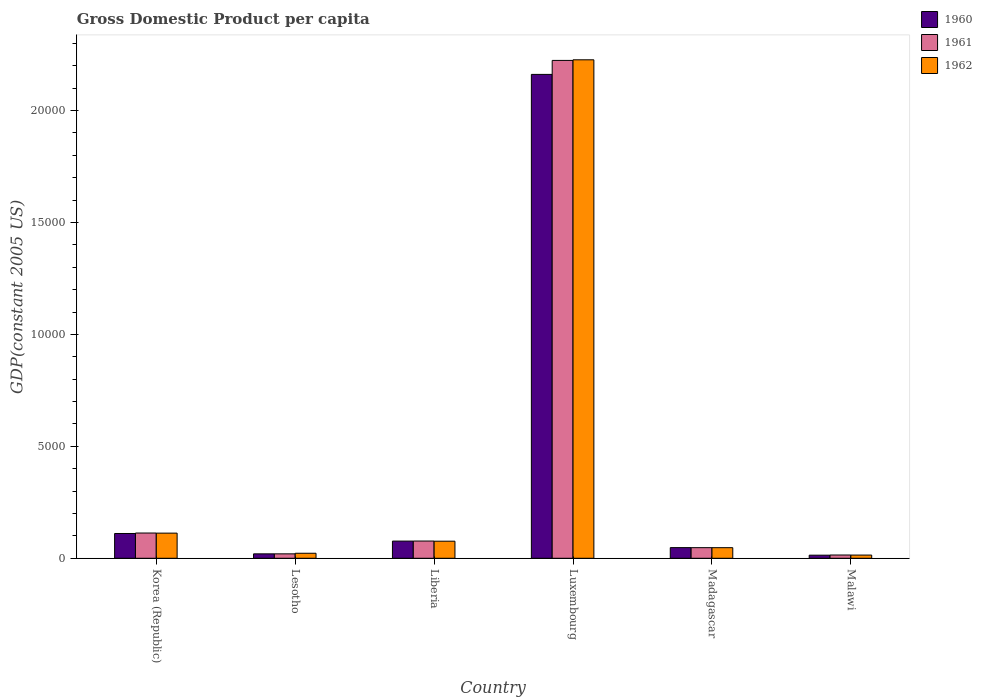How many different coloured bars are there?
Provide a short and direct response. 3. How many groups of bars are there?
Keep it short and to the point. 6. How many bars are there on the 2nd tick from the left?
Provide a succinct answer. 3. How many bars are there on the 3rd tick from the right?
Provide a short and direct response. 3. What is the label of the 1st group of bars from the left?
Your answer should be very brief. Korea (Republic). What is the GDP per capita in 1961 in Madagascar?
Keep it short and to the point. 473.7. Across all countries, what is the maximum GDP per capita in 1960?
Keep it short and to the point. 2.16e+04. Across all countries, what is the minimum GDP per capita in 1962?
Keep it short and to the point. 143.1. In which country was the GDP per capita in 1960 maximum?
Offer a very short reply. Luxembourg. In which country was the GDP per capita in 1962 minimum?
Your answer should be very brief. Malawi. What is the total GDP per capita in 1961 in the graph?
Give a very brief answer. 2.50e+04. What is the difference between the GDP per capita in 1960 in Liberia and that in Madagascar?
Ensure brevity in your answer.  292.1. What is the difference between the GDP per capita in 1961 in Madagascar and the GDP per capita in 1962 in Malawi?
Make the answer very short. 330.6. What is the average GDP per capita in 1960 per country?
Provide a succinct answer. 4049.82. What is the difference between the GDP per capita of/in 1962 and GDP per capita of/in 1961 in Lesotho?
Ensure brevity in your answer.  26.25. In how many countries, is the GDP per capita in 1962 greater than 1000 US$?
Ensure brevity in your answer.  2. What is the ratio of the GDP per capita in 1960 in Liberia to that in Luxembourg?
Your response must be concise. 0.04. What is the difference between the highest and the second highest GDP per capita in 1962?
Offer a very short reply. 2.11e+04. What is the difference between the highest and the lowest GDP per capita in 1962?
Your response must be concise. 2.21e+04. In how many countries, is the GDP per capita in 1960 greater than the average GDP per capita in 1960 taken over all countries?
Offer a terse response. 1. Is the sum of the GDP per capita in 1961 in Liberia and Madagascar greater than the maximum GDP per capita in 1962 across all countries?
Provide a succinct answer. No. What does the 1st bar from the left in Malawi represents?
Your response must be concise. 1960. How many bars are there?
Your answer should be very brief. 18. Are the values on the major ticks of Y-axis written in scientific E-notation?
Your answer should be compact. No. Where does the legend appear in the graph?
Offer a very short reply. Top right. How are the legend labels stacked?
Keep it short and to the point. Vertical. What is the title of the graph?
Offer a terse response. Gross Domestic Product per capita. What is the label or title of the Y-axis?
Keep it short and to the point. GDP(constant 2005 US). What is the GDP(constant 2005 US) of 1960 in Korea (Republic)?
Your answer should be very brief. 1106.76. What is the GDP(constant 2005 US) of 1961 in Korea (Republic)?
Provide a short and direct response. 1127.44. What is the GDP(constant 2005 US) in 1962 in Korea (Republic)?
Give a very brief answer. 1122.59. What is the GDP(constant 2005 US) in 1960 in Lesotho?
Keep it short and to the point. 197.38. What is the GDP(constant 2005 US) of 1961 in Lesotho?
Ensure brevity in your answer.  197.61. What is the GDP(constant 2005 US) in 1962 in Lesotho?
Offer a very short reply. 223.86. What is the GDP(constant 2005 US) in 1960 in Liberia?
Your answer should be very brief. 767.6. What is the GDP(constant 2005 US) of 1961 in Liberia?
Your answer should be very brief. 769.44. What is the GDP(constant 2005 US) of 1962 in Liberia?
Offer a very short reply. 762.88. What is the GDP(constant 2005 US) in 1960 in Luxembourg?
Provide a succinct answer. 2.16e+04. What is the GDP(constant 2005 US) of 1961 in Luxembourg?
Offer a terse response. 2.22e+04. What is the GDP(constant 2005 US) in 1962 in Luxembourg?
Offer a terse response. 2.23e+04. What is the GDP(constant 2005 US) in 1960 in Madagascar?
Provide a succinct answer. 475.5. What is the GDP(constant 2005 US) of 1961 in Madagascar?
Offer a very short reply. 473.7. What is the GDP(constant 2005 US) of 1962 in Madagascar?
Keep it short and to the point. 472.78. What is the GDP(constant 2005 US) of 1960 in Malawi?
Give a very brief answer. 138.11. What is the GDP(constant 2005 US) in 1961 in Malawi?
Give a very brief answer. 145.39. What is the GDP(constant 2005 US) of 1962 in Malawi?
Your response must be concise. 143.1. Across all countries, what is the maximum GDP(constant 2005 US) of 1960?
Provide a short and direct response. 2.16e+04. Across all countries, what is the maximum GDP(constant 2005 US) of 1961?
Your response must be concise. 2.22e+04. Across all countries, what is the maximum GDP(constant 2005 US) of 1962?
Your answer should be compact. 2.23e+04. Across all countries, what is the minimum GDP(constant 2005 US) in 1960?
Keep it short and to the point. 138.11. Across all countries, what is the minimum GDP(constant 2005 US) of 1961?
Make the answer very short. 145.39. Across all countries, what is the minimum GDP(constant 2005 US) in 1962?
Provide a short and direct response. 143.1. What is the total GDP(constant 2005 US) of 1960 in the graph?
Your answer should be very brief. 2.43e+04. What is the total GDP(constant 2005 US) in 1961 in the graph?
Offer a very short reply. 2.50e+04. What is the total GDP(constant 2005 US) of 1962 in the graph?
Your response must be concise. 2.50e+04. What is the difference between the GDP(constant 2005 US) of 1960 in Korea (Republic) and that in Lesotho?
Provide a short and direct response. 909.38. What is the difference between the GDP(constant 2005 US) of 1961 in Korea (Republic) and that in Lesotho?
Make the answer very short. 929.82. What is the difference between the GDP(constant 2005 US) in 1962 in Korea (Republic) and that in Lesotho?
Provide a succinct answer. 898.73. What is the difference between the GDP(constant 2005 US) in 1960 in Korea (Republic) and that in Liberia?
Make the answer very short. 339.16. What is the difference between the GDP(constant 2005 US) of 1961 in Korea (Republic) and that in Liberia?
Provide a short and direct response. 357.99. What is the difference between the GDP(constant 2005 US) of 1962 in Korea (Republic) and that in Liberia?
Provide a succinct answer. 359.71. What is the difference between the GDP(constant 2005 US) of 1960 in Korea (Republic) and that in Luxembourg?
Offer a very short reply. -2.05e+04. What is the difference between the GDP(constant 2005 US) of 1961 in Korea (Republic) and that in Luxembourg?
Provide a short and direct response. -2.11e+04. What is the difference between the GDP(constant 2005 US) of 1962 in Korea (Republic) and that in Luxembourg?
Make the answer very short. -2.11e+04. What is the difference between the GDP(constant 2005 US) in 1960 in Korea (Republic) and that in Madagascar?
Provide a succinct answer. 631.26. What is the difference between the GDP(constant 2005 US) in 1961 in Korea (Republic) and that in Madagascar?
Provide a succinct answer. 653.74. What is the difference between the GDP(constant 2005 US) of 1962 in Korea (Republic) and that in Madagascar?
Give a very brief answer. 649.82. What is the difference between the GDP(constant 2005 US) of 1960 in Korea (Republic) and that in Malawi?
Your answer should be compact. 968.65. What is the difference between the GDP(constant 2005 US) in 1961 in Korea (Republic) and that in Malawi?
Provide a short and direct response. 982.05. What is the difference between the GDP(constant 2005 US) in 1962 in Korea (Republic) and that in Malawi?
Give a very brief answer. 979.49. What is the difference between the GDP(constant 2005 US) in 1960 in Lesotho and that in Liberia?
Provide a short and direct response. -570.22. What is the difference between the GDP(constant 2005 US) of 1961 in Lesotho and that in Liberia?
Provide a short and direct response. -571.83. What is the difference between the GDP(constant 2005 US) of 1962 in Lesotho and that in Liberia?
Provide a succinct answer. -539.02. What is the difference between the GDP(constant 2005 US) of 1960 in Lesotho and that in Luxembourg?
Ensure brevity in your answer.  -2.14e+04. What is the difference between the GDP(constant 2005 US) in 1961 in Lesotho and that in Luxembourg?
Give a very brief answer. -2.20e+04. What is the difference between the GDP(constant 2005 US) in 1962 in Lesotho and that in Luxembourg?
Your response must be concise. -2.20e+04. What is the difference between the GDP(constant 2005 US) of 1960 in Lesotho and that in Madagascar?
Your answer should be very brief. -278.12. What is the difference between the GDP(constant 2005 US) in 1961 in Lesotho and that in Madagascar?
Give a very brief answer. -276.09. What is the difference between the GDP(constant 2005 US) of 1962 in Lesotho and that in Madagascar?
Your answer should be very brief. -248.91. What is the difference between the GDP(constant 2005 US) of 1960 in Lesotho and that in Malawi?
Keep it short and to the point. 59.27. What is the difference between the GDP(constant 2005 US) of 1961 in Lesotho and that in Malawi?
Keep it short and to the point. 52.22. What is the difference between the GDP(constant 2005 US) of 1962 in Lesotho and that in Malawi?
Provide a short and direct response. 80.77. What is the difference between the GDP(constant 2005 US) of 1960 in Liberia and that in Luxembourg?
Provide a succinct answer. -2.08e+04. What is the difference between the GDP(constant 2005 US) in 1961 in Liberia and that in Luxembourg?
Make the answer very short. -2.15e+04. What is the difference between the GDP(constant 2005 US) of 1962 in Liberia and that in Luxembourg?
Ensure brevity in your answer.  -2.15e+04. What is the difference between the GDP(constant 2005 US) in 1960 in Liberia and that in Madagascar?
Your answer should be very brief. 292.1. What is the difference between the GDP(constant 2005 US) of 1961 in Liberia and that in Madagascar?
Your response must be concise. 295.74. What is the difference between the GDP(constant 2005 US) of 1962 in Liberia and that in Madagascar?
Ensure brevity in your answer.  290.11. What is the difference between the GDP(constant 2005 US) of 1960 in Liberia and that in Malawi?
Your response must be concise. 629.48. What is the difference between the GDP(constant 2005 US) in 1961 in Liberia and that in Malawi?
Keep it short and to the point. 624.05. What is the difference between the GDP(constant 2005 US) of 1962 in Liberia and that in Malawi?
Give a very brief answer. 619.78. What is the difference between the GDP(constant 2005 US) of 1960 in Luxembourg and that in Madagascar?
Your answer should be very brief. 2.11e+04. What is the difference between the GDP(constant 2005 US) in 1961 in Luxembourg and that in Madagascar?
Ensure brevity in your answer.  2.18e+04. What is the difference between the GDP(constant 2005 US) in 1962 in Luxembourg and that in Madagascar?
Offer a very short reply. 2.18e+04. What is the difference between the GDP(constant 2005 US) of 1960 in Luxembourg and that in Malawi?
Provide a succinct answer. 2.15e+04. What is the difference between the GDP(constant 2005 US) in 1961 in Luxembourg and that in Malawi?
Your answer should be very brief. 2.21e+04. What is the difference between the GDP(constant 2005 US) in 1962 in Luxembourg and that in Malawi?
Give a very brief answer. 2.21e+04. What is the difference between the GDP(constant 2005 US) of 1960 in Madagascar and that in Malawi?
Give a very brief answer. 337.39. What is the difference between the GDP(constant 2005 US) of 1961 in Madagascar and that in Malawi?
Make the answer very short. 328.31. What is the difference between the GDP(constant 2005 US) of 1962 in Madagascar and that in Malawi?
Keep it short and to the point. 329.68. What is the difference between the GDP(constant 2005 US) of 1960 in Korea (Republic) and the GDP(constant 2005 US) of 1961 in Lesotho?
Provide a succinct answer. 909.15. What is the difference between the GDP(constant 2005 US) in 1960 in Korea (Republic) and the GDP(constant 2005 US) in 1962 in Lesotho?
Offer a terse response. 882.89. What is the difference between the GDP(constant 2005 US) in 1961 in Korea (Republic) and the GDP(constant 2005 US) in 1962 in Lesotho?
Your response must be concise. 903.57. What is the difference between the GDP(constant 2005 US) of 1960 in Korea (Republic) and the GDP(constant 2005 US) of 1961 in Liberia?
Keep it short and to the point. 337.32. What is the difference between the GDP(constant 2005 US) of 1960 in Korea (Republic) and the GDP(constant 2005 US) of 1962 in Liberia?
Provide a short and direct response. 343.88. What is the difference between the GDP(constant 2005 US) of 1961 in Korea (Republic) and the GDP(constant 2005 US) of 1962 in Liberia?
Offer a very short reply. 364.55. What is the difference between the GDP(constant 2005 US) in 1960 in Korea (Republic) and the GDP(constant 2005 US) in 1961 in Luxembourg?
Provide a short and direct response. -2.11e+04. What is the difference between the GDP(constant 2005 US) of 1960 in Korea (Republic) and the GDP(constant 2005 US) of 1962 in Luxembourg?
Give a very brief answer. -2.12e+04. What is the difference between the GDP(constant 2005 US) of 1961 in Korea (Republic) and the GDP(constant 2005 US) of 1962 in Luxembourg?
Offer a terse response. -2.11e+04. What is the difference between the GDP(constant 2005 US) in 1960 in Korea (Republic) and the GDP(constant 2005 US) in 1961 in Madagascar?
Provide a short and direct response. 633.06. What is the difference between the GDP(constant 2005 US) in 1960 in Korea (Republic) and the GDP(constant 2005 US) in 1962 in Madagascar?
Provide a short and direct response. 633.98. What is the difference between the GDP(constant 2005 US) of 1961 in Korea (Republic) and the GDP(constant 2005 US) of 1962 in Madagascar?
Provide a succinct answer. 654.66. What is the difference between the GDP(constant 2005 US) in 1960 in Korea (Republic) and the GDP(constant 2005 US) in 1961 in Malawi?
Make the answer very short. 961.37. What is the difference between the GDP(constant 2005 US) in 1960 in Korea (Republic) and the GDP(constant 2005 US) in 1962 in Malawi?
Provide a short and direct response. 963.66. What is the difference between the GDP(constant 2005 US) in 1961 in Korea (Republic) and the GDP(constant 2005 US) in 1962 in Malawi?
Offer a very short reply. 984.34. What is the difference between the GDP(constant 2005 US) of 1960 in Lesotho and the GDP(constant 2005 US) of 1961 in Liberia?
Your answer should be very brief. -572.07. What is the difference between the GDP(constant 2005 US) of 1960 in Lesotho and the GDP(constant 2005 US) of 1962 in Liberia?
Your answer should be compact. -565.51. What is the difference between the GDP(constant 2005 US) in 1961 in Lesotho and the GDP(constant 2005 US) in 1962 in Liberia?
Keep it short and to the point. -565.27. What is the difference between the GDP(constant 2005 US) in 1960 in Lesotho and the GDP(constant 2005 US) in 1961 in Luxembourg?
Offer a very short reply. -2.20e+04. What is the difference between the GDP(constant 2005 US) of 1960 in Lesotho and the GDP(constant 2005 US) of 1962 in Luxembourg?
Your response must be concise. -2.21e+04. What is the difference between the GDP(constant 2005 US) in 1961 in Lesotho and the GDP(constant 2005 US) in 1962 in Luxembourg?
Offer a very short reply. -2.21e+04. What is the difference between the GDP(constant 2005 US) in 1960 in Lesotho and the GDP(constant 2005 US) in 1961 in Madagascar?
Make the answer very short. -276.32. What is the difference between the GDP(constant 2005 US) of 1960 in Lesotho and the GDP(constant 2005 US) of 1962 in Madagascar?
Offer a terse response. -275.4. What is the difference between the GDP(constant 2005 US) in 1961 in Lesotho and the GDP(constant 2005 US) in 1962 in Madagascar?
Make the answer very short. -275.16. What is the difference between the GDP(constant 2005 US) of 1960 in Lesotho and the GDP(constant 2005 US) of 1961 in Malawi?
Make the answer very short. 51.99. What is the difference between the GDP(constant 2005 US) of 1960 in Lesotho and the GDP(constant 2005 US) of 1962 in Malawi?
Ensure brevity in your answer.  54.28. What is the difference between the GDP(constant 2005 US) of 1961 in Lesotho and the GDP(constant 2005 US) of 1962 in Malawi?
Keep it short and to the point. 54.51. What is the difference between the GDP(constant 2005 US) in 1960 in Liberia and the GDP(constant 2005 US) in 1961 in Luxembourg?
Your response must be concise. -2.15e+04. What is the difference between the GDP(constant 2005 US) of 1960 in Liberia and the GDP(constant 2005 US) of 1962 in Luxembourg?
Provide a short and direct response. -2.15e+04. What is the difference between the GDP(constant 2005 US) in 1961 in Liberia and the GDP(constant 2005 US) in 1962 in Luxembourg?
Your answer should be compact. -2.15e+04. What is the difference between the GDP(constant 2005 US) of 1960 in Liberia and the GDP(constant 2005 US) of 1961 in Madagascar?
Offer a terse response. 293.9. What is the difference between the GDP(constant 2005 US) of 1960 in Liberia and the GDP(constant 2005 US) of 1962 in Madagascar?
Your answer should be very brief. 294.82. What is the difference between the GDP(constant 2005 US) of 1961 in Liberia and the GDP(constant 2005 US) of 1962 in Madagascar?
Make the answer very short. 296.67. What is the difference between the GDP(constant 2005 US) in 1960 in Liberia and the GDP(constant 2005 US) in 1961 in Malawi?
Offer a very short reply. 622.21. What is the difference between the GDP(constant 2005 US) in 1960 in Liberia and the GDP(constant 2005 US) in 1962 in Malawi?
Give a very brief answer. 624.5. What is the difference between the GDP(constant 2005 US) in 1961 in Liberia and the GDP(constant 2005 US) in 1962 in Malawi?
Your response must be concise. 626.34. What is the difference between the GDP(constant 2005 US) in 1960 in Luxembourg and the GDP(constant 2005 US) in 1961 in Madagascar?
Your answer should be compact. 2.11e+04. What is the difference between the GDP(constant 2005 US) of 1960 in Luxembourg and the GDP(constant 2005 US) of 1962 in Madagascar?
Your answer should be compact. 2.11e+04. What is the difference between the GDP(constant 2005 US) in 1961 in Luxembourg and the GDP(constant 2005 US) in 1962 in Madagascar?
Your response must be concise. 2.18e+04. What is the difference between the GDP(constant 2005 US) in 1960 in Luxembourg and the GDP(constant 2005 US) in 1961 in Malawi?
Make the answer very short. 2.15e+04. What is the difference between the GDP(constant 2005 US) in 1960 in Luxembourg and the GDP(constant 2005 US) in 1962 in Malawi?
Your answer should be very brief. 2.15e+04. What is the difference between the GDP(constant 2005 US) in 1961 in Luxembourg and the GDP(constant 2005 US) in 1962 in Malawi?
Your answer should be compact. 2.21e+04. What is the difference between the GDP(constant 2005 US) in 1960 in Madagascar and the GDP(constant 2005 US) in 1961 in Malawi?
Give a very brief answer. 330.11. What is the difference between the GDP(constant 2005 US) in 1960 in Madagascar and the GDP(constant 2005 US) in 1962 in Malawi?
Your answer should be compact. 332.4. What is the difference between the GDP(constant 2005 US) in 1961 in Madagascar and the GDP(constant 2005 US) in 1962 in Malawi?
Give a very brief answer. 330.6. What is the average GDP(constant 2005 US) in 1960 per country?
Your answer should be very brief. 4049.82. What is the average GDP(constant 2005 US) of 1961 per country?
Offer a very short reply. 4158.55. What is the average GDP(constant 2005 US) of 1962 per country?
Ensure brevity in your answer.  4165.11. What is the difference between the GDP(constant 2005 US) of 1960 and GDP(constant 2005 US) of 1961 in Korea (Republic)?
Keep it short and to the point. -20.68. What is the difference between the GDP(constant 2005 US) in 1960 and GDP(constant 2005 US) in 1962 in Korea (Republic)?
Give a very brief answer. -15.83. What is the difference between the GDP(constant 2005 US) of 1961 and GDP(constant 2005 US) of 1962 in Korea (Republic)?
Your response must be concise. 4.85. What is the difference between the GDP(constant 2005 US) in 1960 and GDP(constant 2005 US) in 1961 in Lesotho?
Give a very brief answer. -0.24. What is the difference between the GDP(constant 2005 US) in 1960 and GDP(constant 2005 US) in 1962 in Lesotho?
Give a very brief answer. -26.49. What is the difference between the GDP(constant 2005 US) in 1961 and GDP(constant 2005 US) in 1962 in Lesotho?
Give a very brief answer. -26.25. What is the difference between the GDP(constant 2005 US) of 1960 and GDP(constant 2005 US) of 1961 in Liberia?
Your answer should be compact. -1.85. What is the difference between the GDP(constant 2005 US) of 1960 and GDP(constant 2005 US) of 1962 in Liberia?
Make the answer very short. 4.71. What is the difference between the GDP(constant 2005 US) of 1961 and GDP(constant 2005 US) of 1962 in Liberia?
Give a very brief answer. 6.56. What is the difference between the GDP(constant 2005 US) of 1960 and GDP(constant 2005 US) of 1961 in Luxembourg?
Your answer should be very brief. -624.17. What is the difference between the GDP(constant 2005 US) of 1960 and GDP(constant 2005 US) of 1962 in Luxembourg?
Offer a very short reply. -651.89. What is the difference between the GDP(constant 2005 US) of 1961 and GDP(constant 2005 US) of 1962 in Luxembourg?
Provide a short and direct response. -27.73. What is the difference between the GDP(constant 2005 US) in 1960 and GDP(constant 2005 US) in 1961 in Madagascar?
Your answer should be very brief. 1.8. What is the difference between the GDP(constant 2005 US) of 1960 and GDP(constant 2005 US) of 1962 in Madagascar?
Offer a very short reply. 2.72. What is the difference between the GDP(constant 2005 US) of 1961 and GDP(constant 2005 US) of 1962 in Madagascar?
Make the answer very short. 0.92. What is the difference between the GDP(constant 2005 US) of 1960 and GDP(constant 2005 US) of 1961 in Malawi?
Provide a short and direct response. -7.28. What is the difference between the GDP(constant 2005 US) of 1960 and GDP(constant 2005 US) of 1962 in Malawi?
Your answer should be compact. -4.99. What is the difference between the GDP(constant 2005 US) of 1961 and GDP(constant 2005 US) of 1962 in Malawi?
Provide a short and direct response. 2.29. What is the ratio of the GDP(constant 2005 US) in 1960 in Korea (Republic) to that in Lesotho?
Provide a succinct answer. 5.61. What is the ratio of the GDP(constant 2005 US) of 1961 in Korea (Republic) to that in Lesotho?
Your answer should be compact. 5.71. What is the ratio of the GDP(constant 2005 US) of 1962 in Korea (Republic) to that in Lesotho?
Provide a short and direct response. 5.01. What is the ratio of the GDP(constant 2005 US) in 1960 in Korea (Republic) to that in Liberia?
Provide a short and direct response. 1.44. What is the ratio of the GDP(constant 2005 US) of 1961 in Korea (Republic) to that in Liberia?
Your response must be concise. 1.47. What is the ratio of the GDP(constant 2005 US) of 1962 in Korea (Republic) to that in Liberia?
Give a very brief answer. 1.47. What is the ratio of the GDP(constant 2005 US) in 1960 in Korea (Republic) to that in Luxembourg?
Provide a succinct answer. 0.05. What is the ratio of the GDP(constant 2005 US) in 1961 in Korea (Republic) to that in Luxembourg?
Your response must be concise. 0.05. What is the ratio of the GDP(constant 2005 US) of 1962 in Korea (Republic) to that in Luxembourg?
Your answer should be very brief. 0.05. What is the ratio of the GDP(constant 2005 US) in 1960 in Korea (Republic) to that in Madagascar?
Give a very brief answer. 2.33. What is the ratio of the GDP(constant 2005 US) of 1961 in Korea (Republic) to that in Madagascar?
Ensure brevity in your answer.  2.38. What is the ratio of the GDP(constant 2005 US) of 1962 in Korea (Republic) to that in Madagascar?
Your answer should be compact. 2.37. What is the ratio of the GDP(constant 2005 US) in 1960 in Korea (Republic) to that in Malawi?
Keep it short and to the point. 8.01. What is the ratio of the GDP(constant 2005 US) in 1961 in Korea (Republic) to that in Malawi?
Ensure brevity in your answer.  7.75. What is the ratio of the GDP(constant 2005 US) in 1962 in Korea (Republic) to that in Malawi?
Offer a very short reply. 7.84. What is the ratio of the GDP(constant 2005 US) in 1960 in Lesotho to that in Liberia?
Your answer should be very brief. 0.26. What is the ratio of the GDP(constant 2005 US) of 1961 in Lesotho to that in Liberia?
Give a very brief answer. 0.26. What is the ratio of the GDP(constant 2005 US) in 1962 in Lesotho to that in Liberia?
Your response must be concise. 0.29. What is the ratio of the GDP(constant 2005 US) in 1960 in Lesotho to that in Luxembourg?
Your answer should be very brief. 0.01. What is the ratio of the GDP(constant 2005 US) in 1961 in Lesotho to that in Luxembourg?
Keep it short and to the point. 0.01. What is the ratio of the GDP(constant 2005 US) of 1962 in Lesotho to that in Luxembourg?
Your answer should be compact. 0.01. What is the ratio of the GDP(constant 2005 US) of 1960 in Lesotho to that in Madagascar?
Your answer should be compact. 0.42. What is the ratio of the GDP(constant 2005 US) in 1961 in Lesotho to that in Madagascar?
Provide a short and direct response. 0.42. What is the ratio of the GDP(constant 2005 US) of 1962 in Lesotho to that in Madagascar?
Keep it short and to the point. 0.47. What is the ratio of the GDP(constant 2005 US) in 1960 in Lesotho to that in Malawi?
Give a very brief answer. 1.43. What is the ratio of the GDP(constant 2005 US) of 1961 in Lesotho to that in Malawi?
Offer a very short reply. 1.36. What is the ratio of the GDP(constant 2005 US) of 1962 in Lesotho to that in Malawi?
Keep it short and to the point. 1.56. What is the ratio of the GDP(constant 2005 US) in 1960 in Liberia to that in Luxembourg?
Give a very brief answer. 0.04. What is the ratio of the GDP(constant 2005 US) in 1961 in Liberia to that in Luxembourg?
Provide a short and direct response. 0.03. What is the ratio of the GDP(constant 2005 US) of 1962 in Liberia to that in Luxembourg?
Provide a short and direct response. 0.03. What is the ratio of the GDP(constant 2005 US) in 1960 in Liberia to that in Madagascar?
Offer a terse response. 1.61. What is the ratio of the GDP(constant 2005 US) in 1961 in Liberia to that in Madagascar?
Keep it short and to the point. 1.62. What is the ratio of the GDP(constant 2005 US) in 1962 in Liberia to that in Madagascar?
Provide a short and direct response. 1.61. What is the ratio of the GDP(constant 2005 US) of 1960 in Liberia to that in Malawi?
Provide a succinct answer. 5.56. What is the ratio of the GDP(constant 2005 US) of 1961 in Liberia to that in Malawi?
Ensure brevity in your answer.  5.29. What is the ratio of the GDP(constant 2005 US) of 1962 in Liberia to that in Malawi?
Ensure brevity in your answer.  5.33. What is the ratio of the GDP(constant 2005 US) of 1960 in Luxembourg to that in Madagascar?
Offer a terse response. 45.45. What is the ratio of the GDP(constant 2005 US) in 1961 in Luxembourg to that in Madagascar?
Make the answer very short. 46.95. What is the ratio of the GDP(constant 2005 US) of 1962 in Luxembourg to that in Madagascar?
Provide a succinct answer. 47.1. What is the ratio of the GDP(constant 2005 US) in 1960 in Luxembourg to that in Malawi?
Your answer should be compact. 156.49. What is the ratio of the GDP(constant 2005 US) in 1961 in Luxembourg to that in Malawi?
Give a very brief answer. 152.95. What is the ratio of the GDP(constant 2005 US) in 1962 in Luxembourg to that in Malawi?
Offer a terse response. 155.6. What is the ratio of the GDP(constant 2005 US) in 1960 in Madagascar to that in Malawi?
Your response must be concise. 3.44. What is the ratio of the GDP(constant 2005 US) of 1961 in Madagascar to that in Malawi?
Ensure brevity in your answer.  3.26. What is the ratio of the GDP(constant 2005 US) in 1962 in Madagascar to that in Malawi?
Keep it short and to the point. 3.3. What is the difference between the highest and the second highest GDP(constant 2005 US) of 1960?
Provide a short and direct response. 2.05e+04. What is the difference between the highest and the second highest GDP(constant 2005 US) in 1961?
Make the answer very short. 2.11e+04. What is the difference between the highest and the second highest GDP(constant 2005 US) of 1962?
Make the answer very short. 2.11e+04. What is the difference between the highest and the lowest GDP(constant 2005 US) of 1960?
Provide a succinct answer. 2.15e+04. What is the difference between the highest and the lowest GDP(constant 2005 US) of 1961?
Your answer should be compact. 2.21e+04. What is the difference between the highest and the lowest GDP(constant 2005 US) of 1962?
Give a very brief answer. 2.21e+04. 